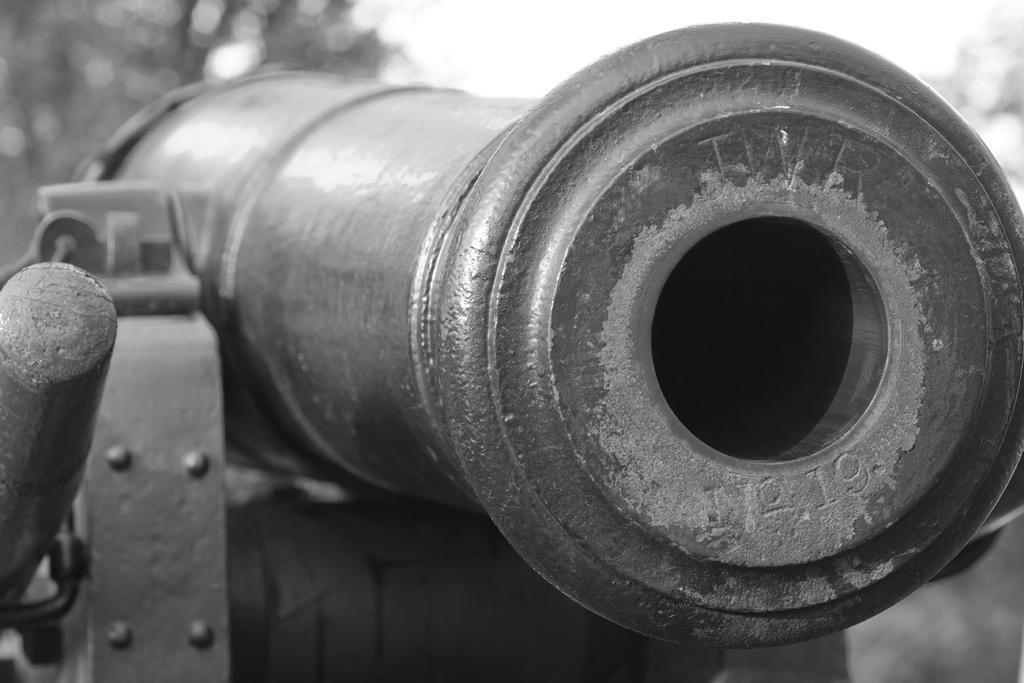What is the main object in the image? There is a canon in the image. What can be seen in the background of the image? There are trees in the background of the image. What is visible at the top of the image? The sky is visible at the top of the image. Can you describe any other objects in the image? There might be a wooden stick in the image. How many horses are present in the image? There are no horses present in the image; it features a canon and possibly a wooden stick. What message of peace can be seen in the image? There is no message of peace depicted in the image; it focuses on the canon and the surrounding environment. 